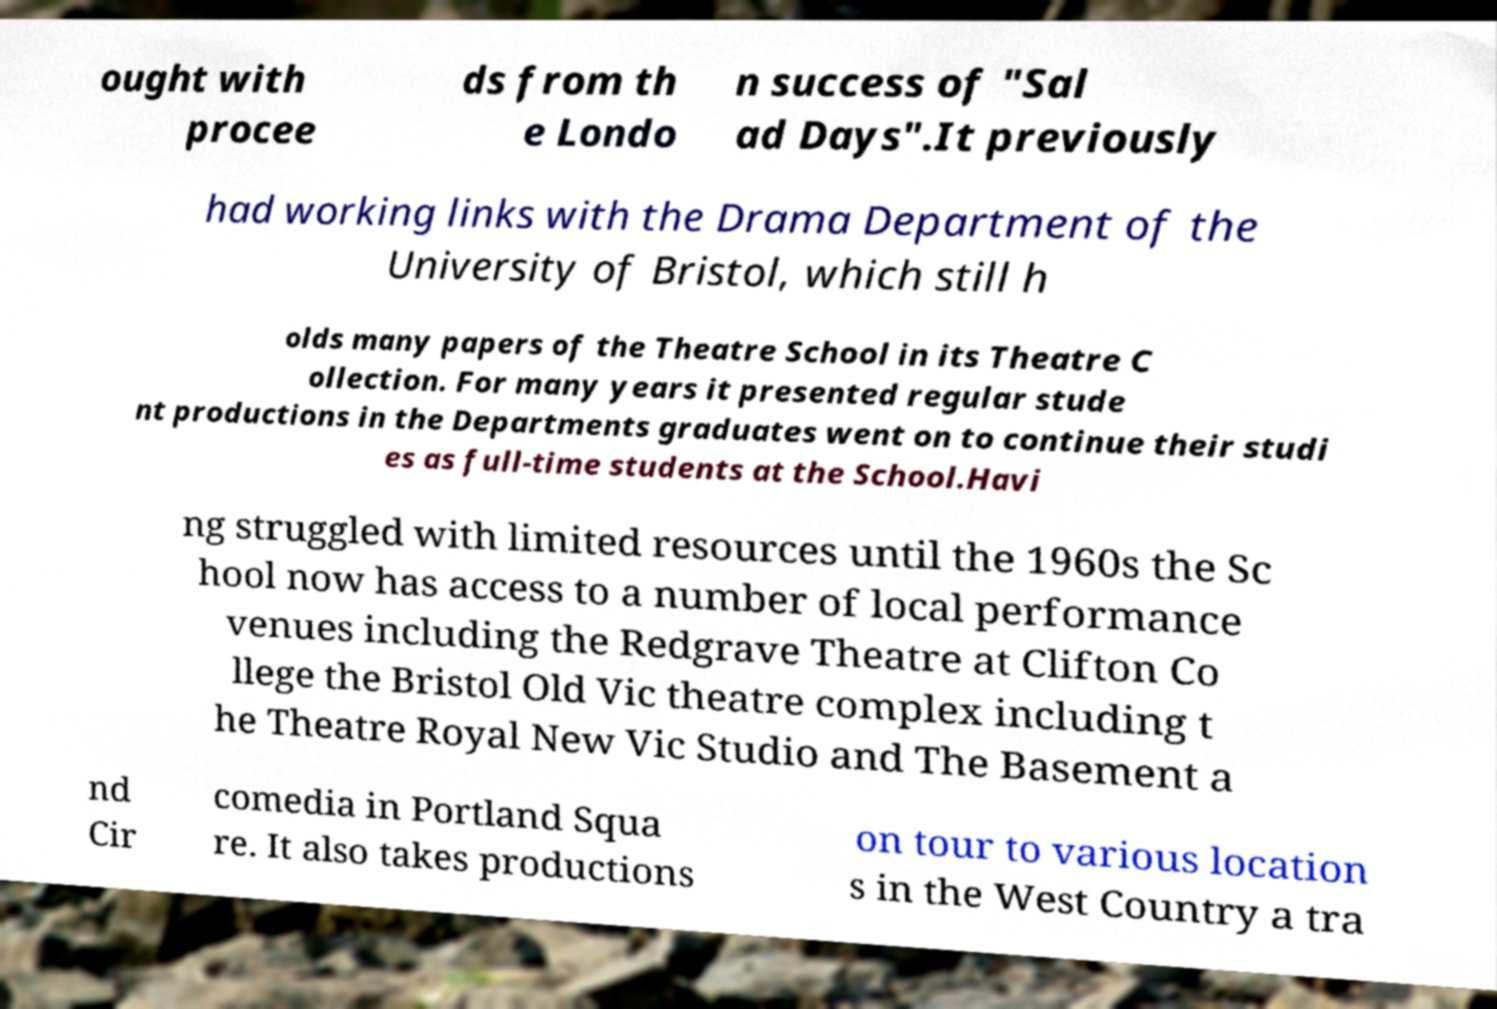I need the written content from this picture converted into text. Can you do that? ought with procee ds from th e Londo n success of "Sal ad Days".It previously had working links with the Drama Department of the University of Bristol, which still h olds many papers of the Theatre School in its Theatre C ollection. For many years it presented regular stude nt productions in the Departments graduates went on to continue their studi es as full-time students at the School.Havi ng struggled with limited resources until the 1960s the Sc hool now has access to a number of local performance venues including the Redgrave Theatre at Clifton Co llege the Bristol Old Vic theatre complex including t he Theatre Royal New Vic Studio and The Basement a nd Cir comedia in Portland Squa re. It also takes productions on tour to various location s in the West Country a tra 